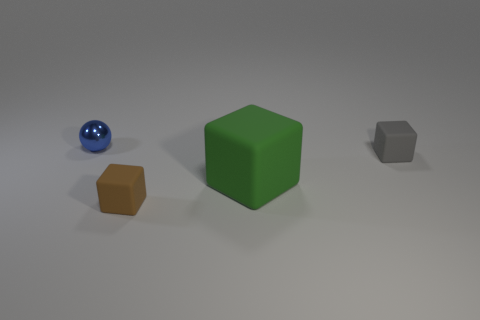What number of other objects are the same size as the brown thing?
Offer a very short reply. 2. The tiny object that is right of the small block to the left of the small matte object behind the big rubber thing is what shape?
Provide a short and direct response. Cube. Do the gray cube and the object that is behind the gray rubber thing have the same size?
Your answer should be compact. Yes. The tiny thing that is both to the left of the large green matte thing and to the right of the blue shiny ball is what color?
Keep it short and to the point. Brown. What number of other objects are there of the same shape as the small gray object?
Your answer should be compact. 2. There is a matte thing that is in front of the large green matte thing; does it have the same color as the tiny matte object that is right of the green cube?
Give a very brief answer. No. Is the size of the blue sphere that is behind the gray rubber object the same as the matte thing in front of the large object?
Your response must be concise. Yes. Is there any other thing that has the same material as the big green object?
Provide a short and direct response. Yes. There is a small object in front of the small object to the right of the thing that is in front of the green block; what is its material?
Provide a succinct answer. Rubber. Does the large thing have the same shape as the small blue thing?
Provide a succinct answer. No. 